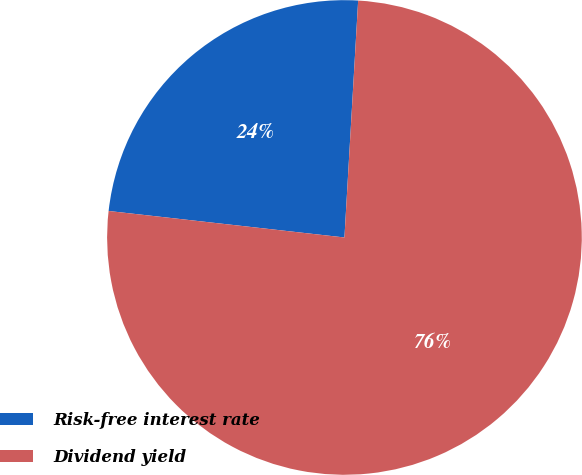Convert chart to OTSL. <chart><loc_0><loc_0><loc_500><loc_500><pie_chart><fcel>Risk-free interest rate<fcel>Dividend yield<nl><fcel>24.14%<fcel>75.86%<nl></chart> 